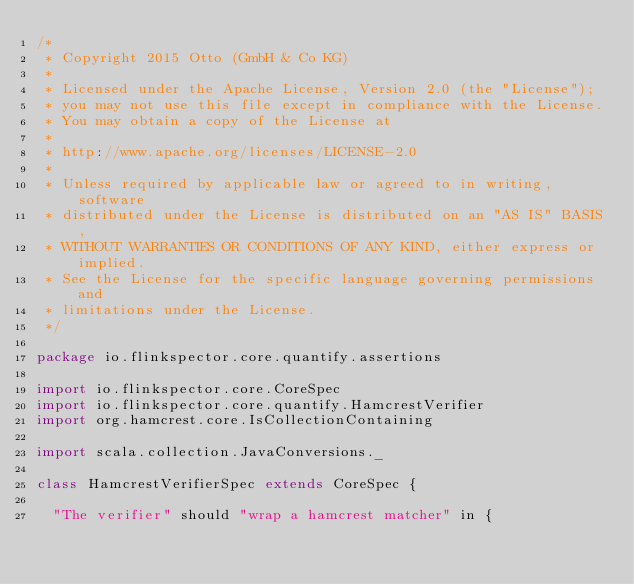<code> <loc_0><loc_0><loc_500><loc_500><_Scala_>/*
 * Copyright 2015 Otto (GmbH & Co KG)
 *
 * Licensed under the Apache License, Version 2.0 (the "License");
 * you may not use this file except in compliance with the License.
 * You may obtain a copy of the License at
 *
 * http://www.apache.org/licenses/LICENSE-2.0
 *
 * Unless required by applicable law or agreed to in writing, software
 * distributed under the License is distributed on an "AS IS" BASIS,
 * WITHOUT WARRANTIES OR CONDITIONS OF ANY KIND, either express or implied.
 * See the License for the specific language governing permissions and
 * limitations under the License.
 */

package io.flinkspector.core.quantify.assertions

import io.flinkspector.core.CoreSpec
import io.flinkspector.core.quantify.HamcrestVerifier
import org.hamcrest.core.IsCollectionContaining

import scala.collection.JavaConversions._

class HamcrestVerifierSpec extends CoreSpec {

  "The verifier" should "wrap a hamcrest matcher" in {</code> 